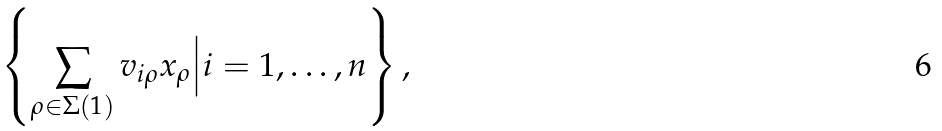Convert formula to latex. <formula><loc_0><loc_0><loc_500><loc_500>\left \{ \sum _ { \rho \in \Sigma ( 1 ) } v _ { i \rho } x _ { \rho } \Big | i = 1 , \dots , n \right \} ,</formula> 